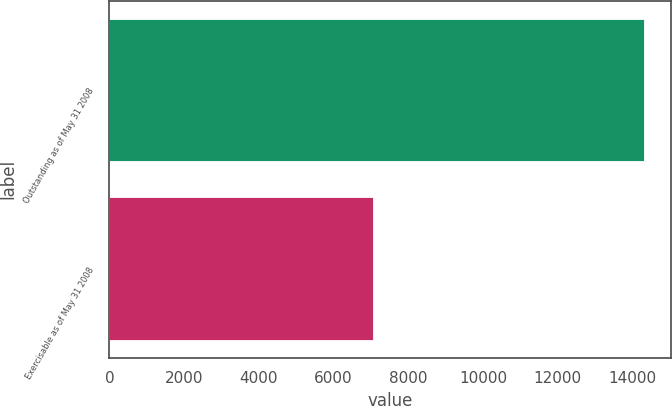<chart> <loc_0><loc_0><loc_500><loc_500><bar_chart><fcel>Outstanding as of May 31 2008<fcel>Exercisable as of May 31 2008<nl><fcel>14308<fcel>7068<nl></chart> 